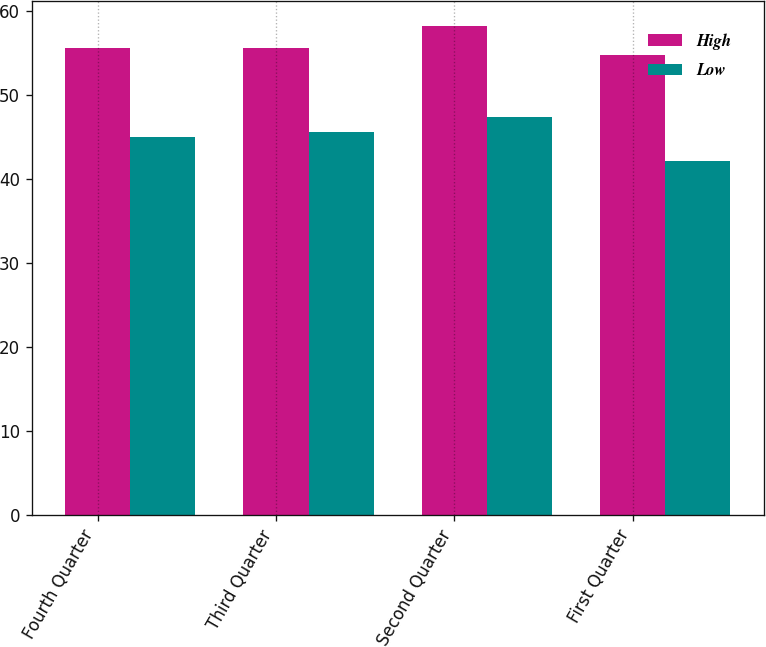<chart> <loc_0><loc_0><loc_500><loc_500><stacked_bar_chart><ecel><fcel>Fourth Quarter<fcel>Third Quarter<fcel>Second Quarter<fcel>First Quarter<nl><fcel>High<fcel>55.5<fcel>55.57<fcel>58.19<fcel>54.67<nl><fcel>Low<fcel>45.01<fcel>45.54<fcel>47.39<fcel>42.11<nl></chart> 